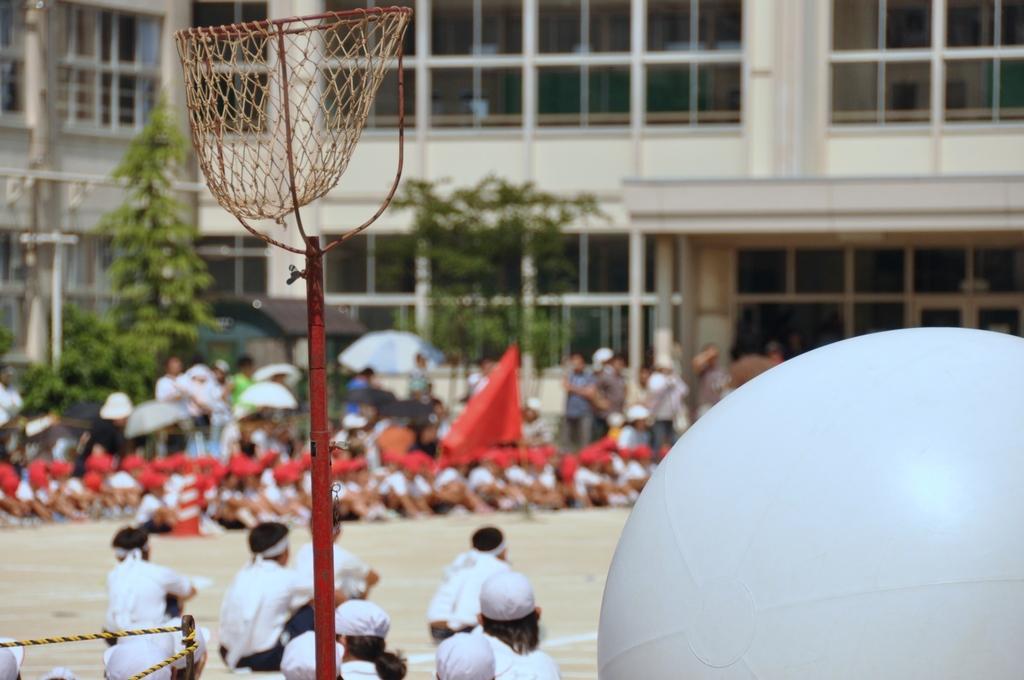How would you summarize this image in a sentence or two? In the foreground of the image I can see an object which is in white color on the right side of the image and a net here. The background of the image is slightly blurred, where we can see a few people are sitting on the ground, we can see red color flag, few people standing, I can see trees and a building. 